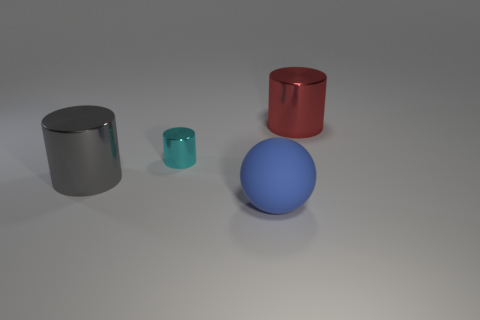Subtract all balls. How many objects are left? 3 Subtract 1 spheres. How many spheres are left? 0 Subtract all purple spheres. Subtract all blue cylinders. How many spheres are left? 1 Subtract all purple cubes. How many cyan cylinders are left? 1 Subtract all big cyan rubber balls. Subtract all blue objects. How many objects are left? 3 Add 2 tiny cylinders. How many tiny cylinders are left? 3 Add 3 red cylinders. How many red cylinders exist? 4 Add 1 large red metal objects. How many objects exist? 5 Subtract all gray cylinders. How many cylinders are left? 2 Subtract all tiny cyan cylinders. How many cylinders are left? 2 